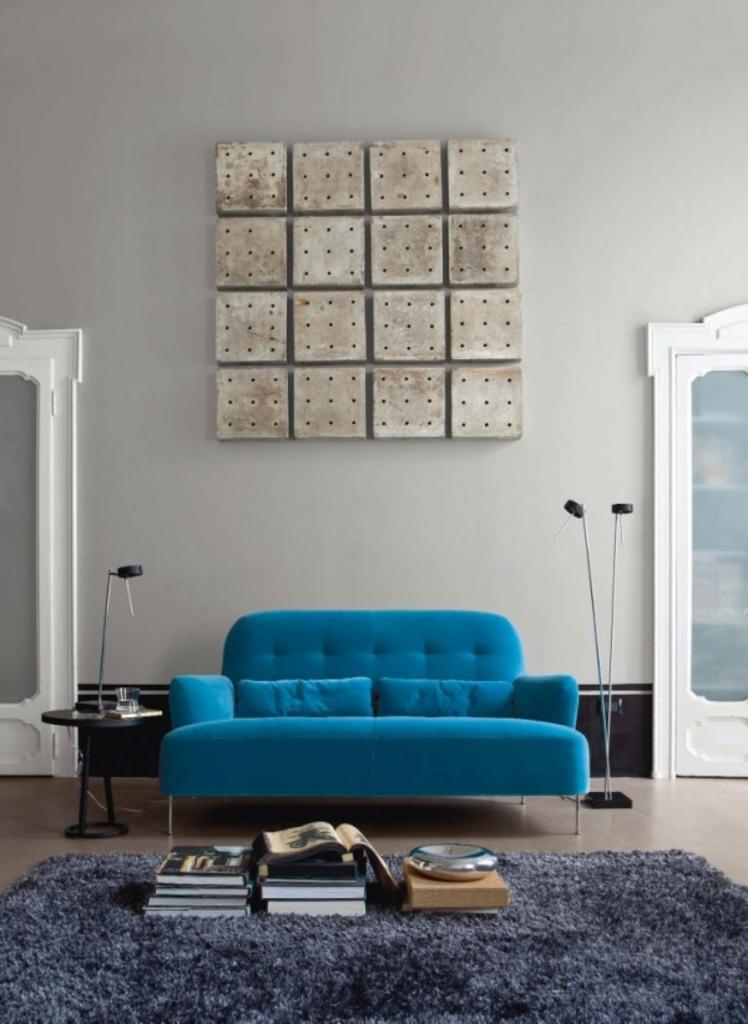Can you describe this image briefly? this is an indoor picture. here we can see a sofa which is blue in colour. This is a floor mat. Here we can see few books. These are the cupboards in between the sofa. On the background we can see a wall and this is a dice show piece over the wall. 